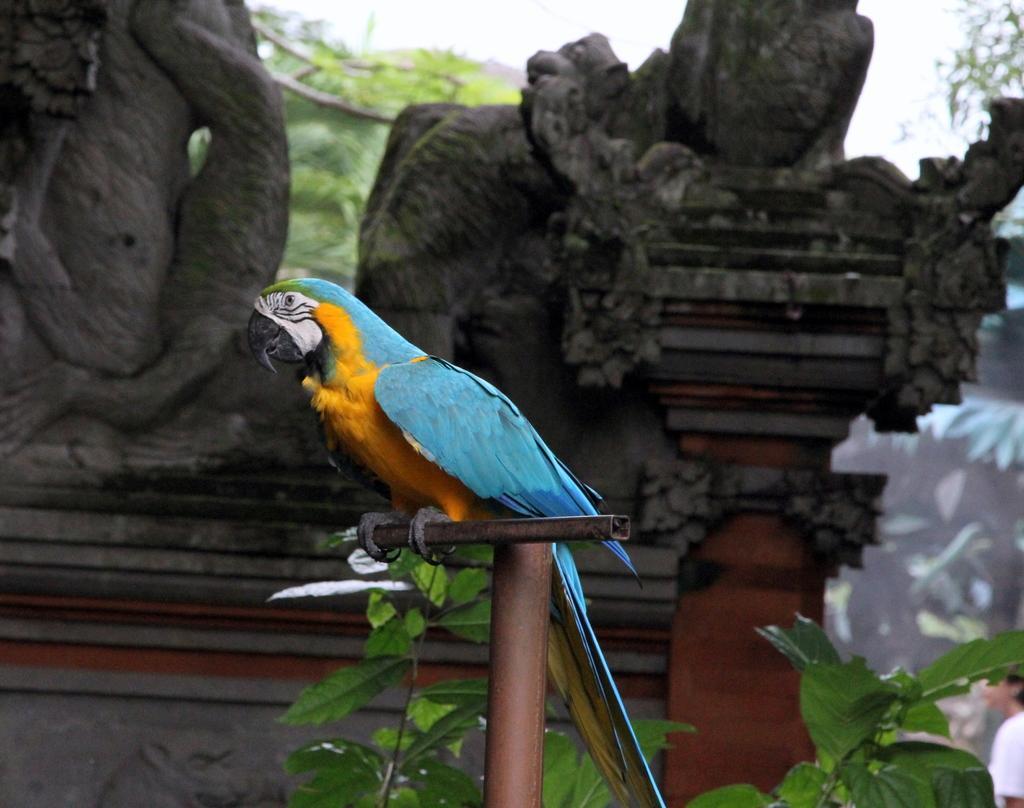Describe this image in one or two sentences. In this picture we can see a macaw in the front, there are sculptures in the middle, in the background there are trees, we can see the sky at the top of the picture. 